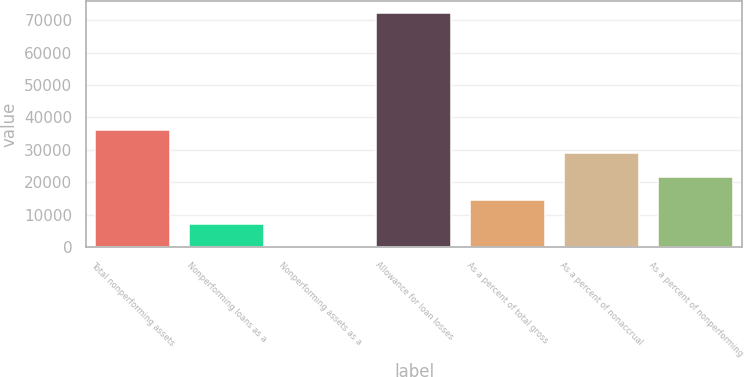<chart> <loc_0><loc_0><loc_500><loc_500><bar_chart><fcel>Total nonperforming assets<fcel>Nonperforming loans as a<fcel>Nonperforming assets as a<fcel>Allowance for loan losses<fcel>As a percent of total gross<fcel>As a percent of nonaccrual<fcel>As a percent of nonperforming<nl><fcel>36187.7<fcel>7237.86<fcel>0.4<fcel>72375<fcel>14475.3<fcel>28950.2<fcel>21712.8<nl></chart> 